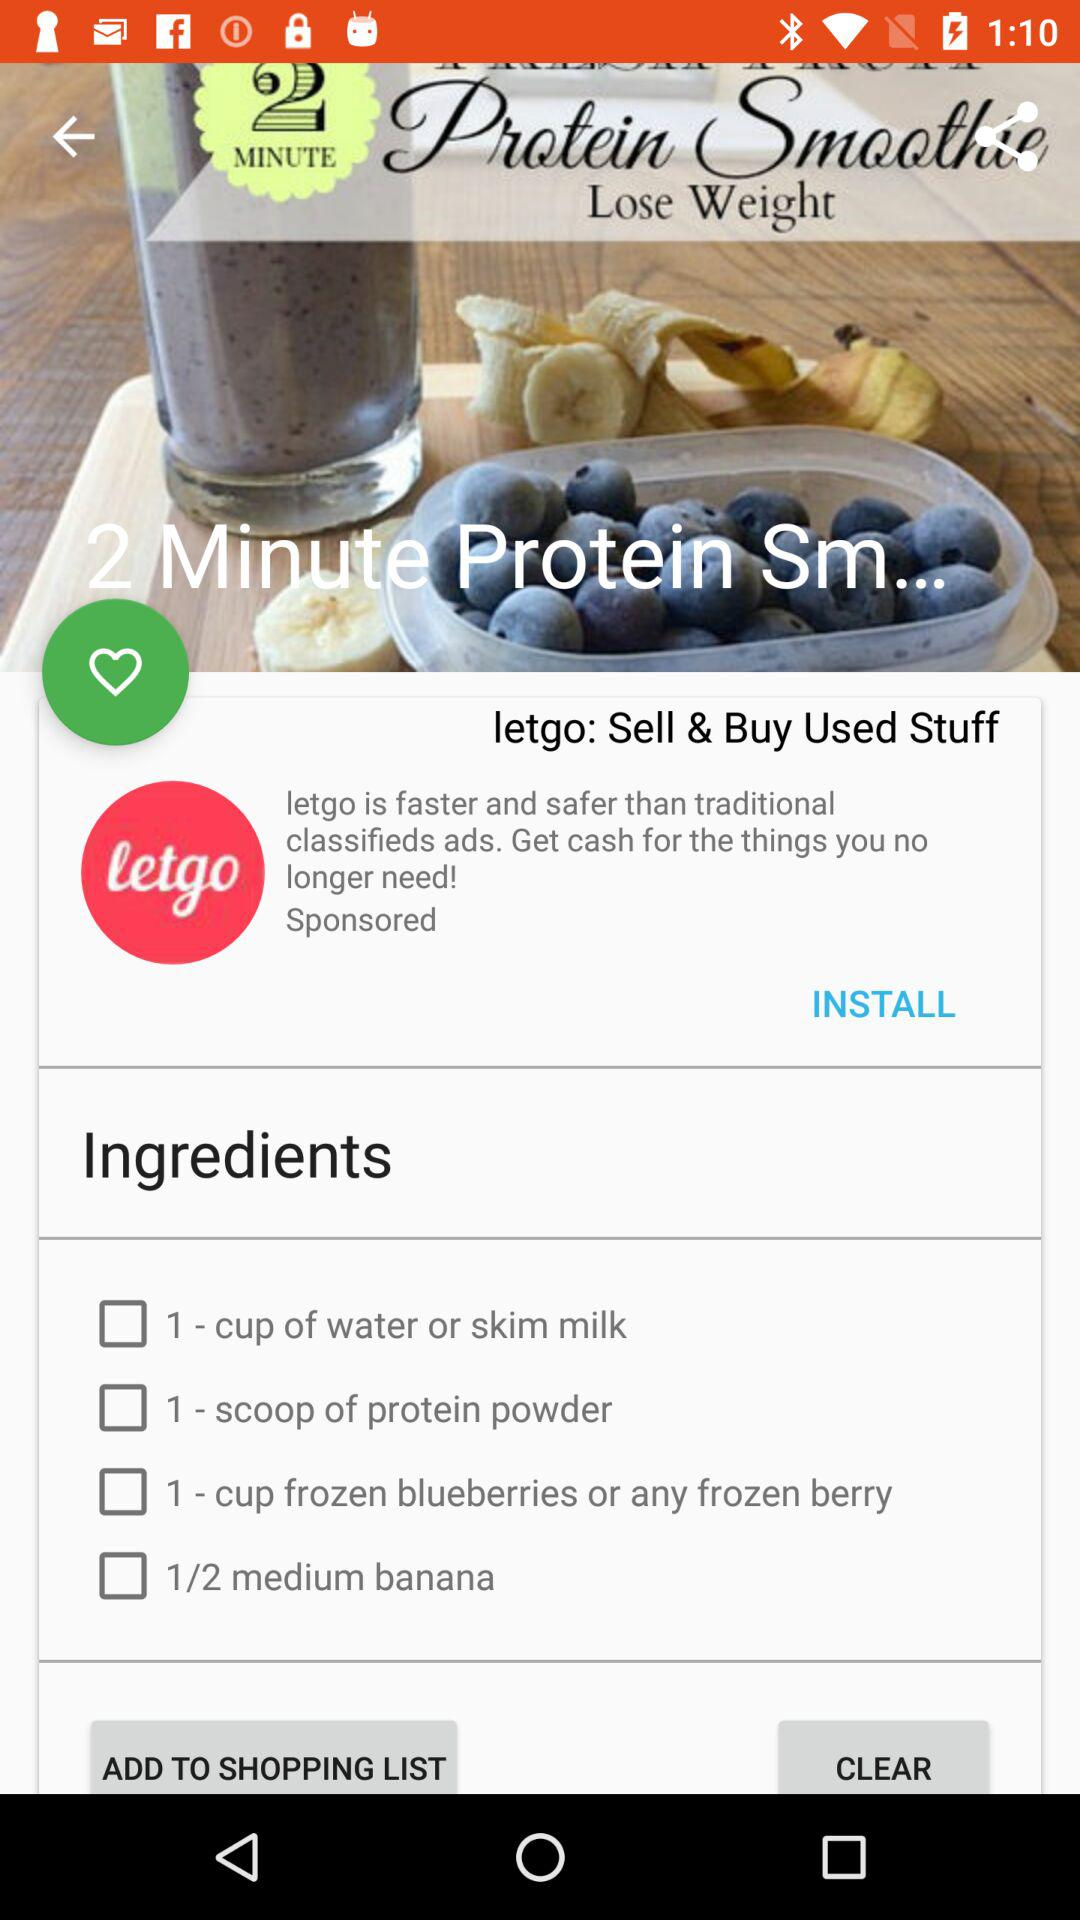How many ingredients are in the recipe?
Answer the question using a single word or phrase. 4 